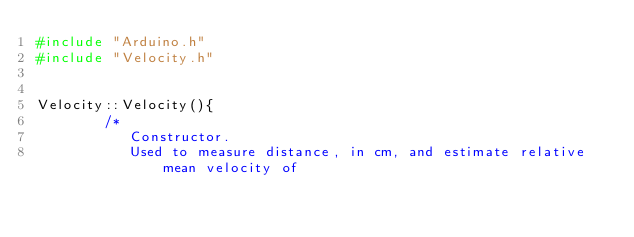Convert code to text. <code><loc_0><loc_0><loc_500><loc_500><_C++_>#include "Arduino.h"
#include "Velocity.h"


Velocity::Velocity(){
        /*
           Constructor.
           Used to measure distance, in cm, and estimate relative mean velocity of</code> 